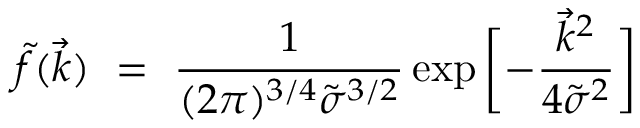<formula> <loc_0><loc_0><loc_500><loc_500>\tilde { f } ( \vec { k } ) \ = \ \frac { 1 } { ( 2 \pi ) ^ { 3 / 4 } \tilde { \sigma } ^ { 3 / 2 } } \exp { \left [ - \frac { \vec { k } ^ { 2 } } { 4 \tilde { \sigma } ^ { 2 } } \right ] }</formula> 